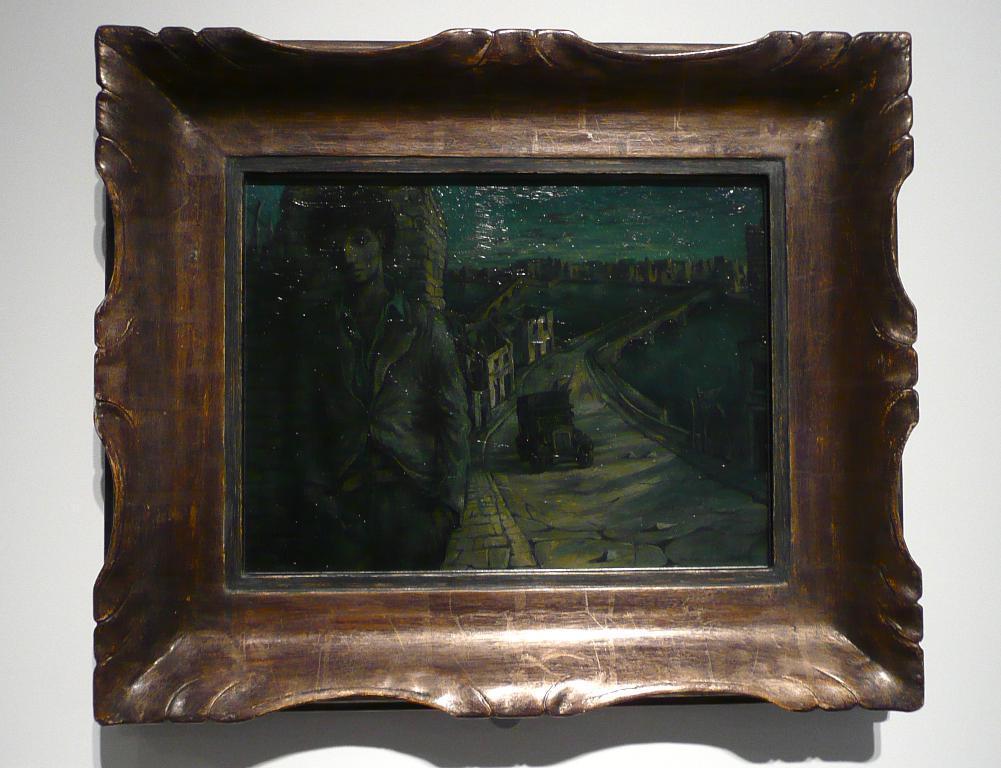Can you describe this image briefly? In this image there is a photo frame on the wall. 